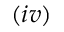Convert formula to latex. <formula><loc_0><loc_0><loc_500><loc_500>( i v )</formula> 